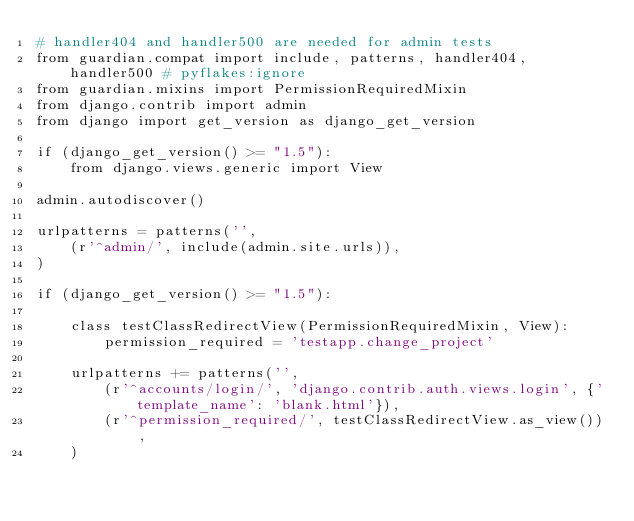Convert code to text. <code><loc_0><loc_0><loc_500><loc_500><_Python_># handler404 and handler500 are needed for admin tests
from guardian.compat import include, patterns, handler404, handler500 # pyflakes:ignore
from guardian.mixins import PermissionRequiredMixin
from django.contrib import admin
from django import get_version as django_get_version

if (django_get_version() >= "1.5"):
    from django.views.generic import View

admin.autodiscover()

urlpatterns = patterns('',
    (r'^admin/', include(admin.site.urls)),
)

if (django_get_version() >= "1.5"):

    class testClassRedirectView(PermissionRequiredMixin, View):
        permission_required = 'testapp.change_project'

    urlpatterns += patterns('',
        (r'^accounts/login/', 'django.contrib.auth.views.login', {'template_name': 'blank.html'}),
        (r'^permission_required/', testClassRedirectView.as_view()),
    )
</code> 